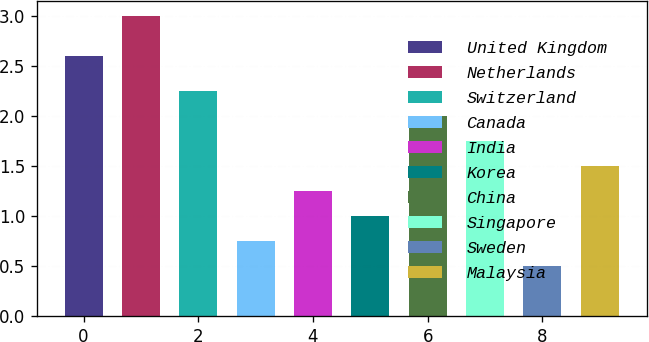Convert chart to OTSL. <chart><loc_0><loc_0><loc_500><loc_500><bar_chart><fcel>United Kingdom<fcel>Netherlands<fcel>Switzerland<fcel>Canada<fcel>India<fcel>Korea<fcel>China<fcel>Singapore<fcel>Sweden<fcel>Malaysia<nl><fcel>2.6<fcel>3<fcel>2.25<fcel>0.75<fcel>1.25<fcel>1<fcel>2<fcel>1.75<fcel>0.5<fcel>1.5<nl></chart> 